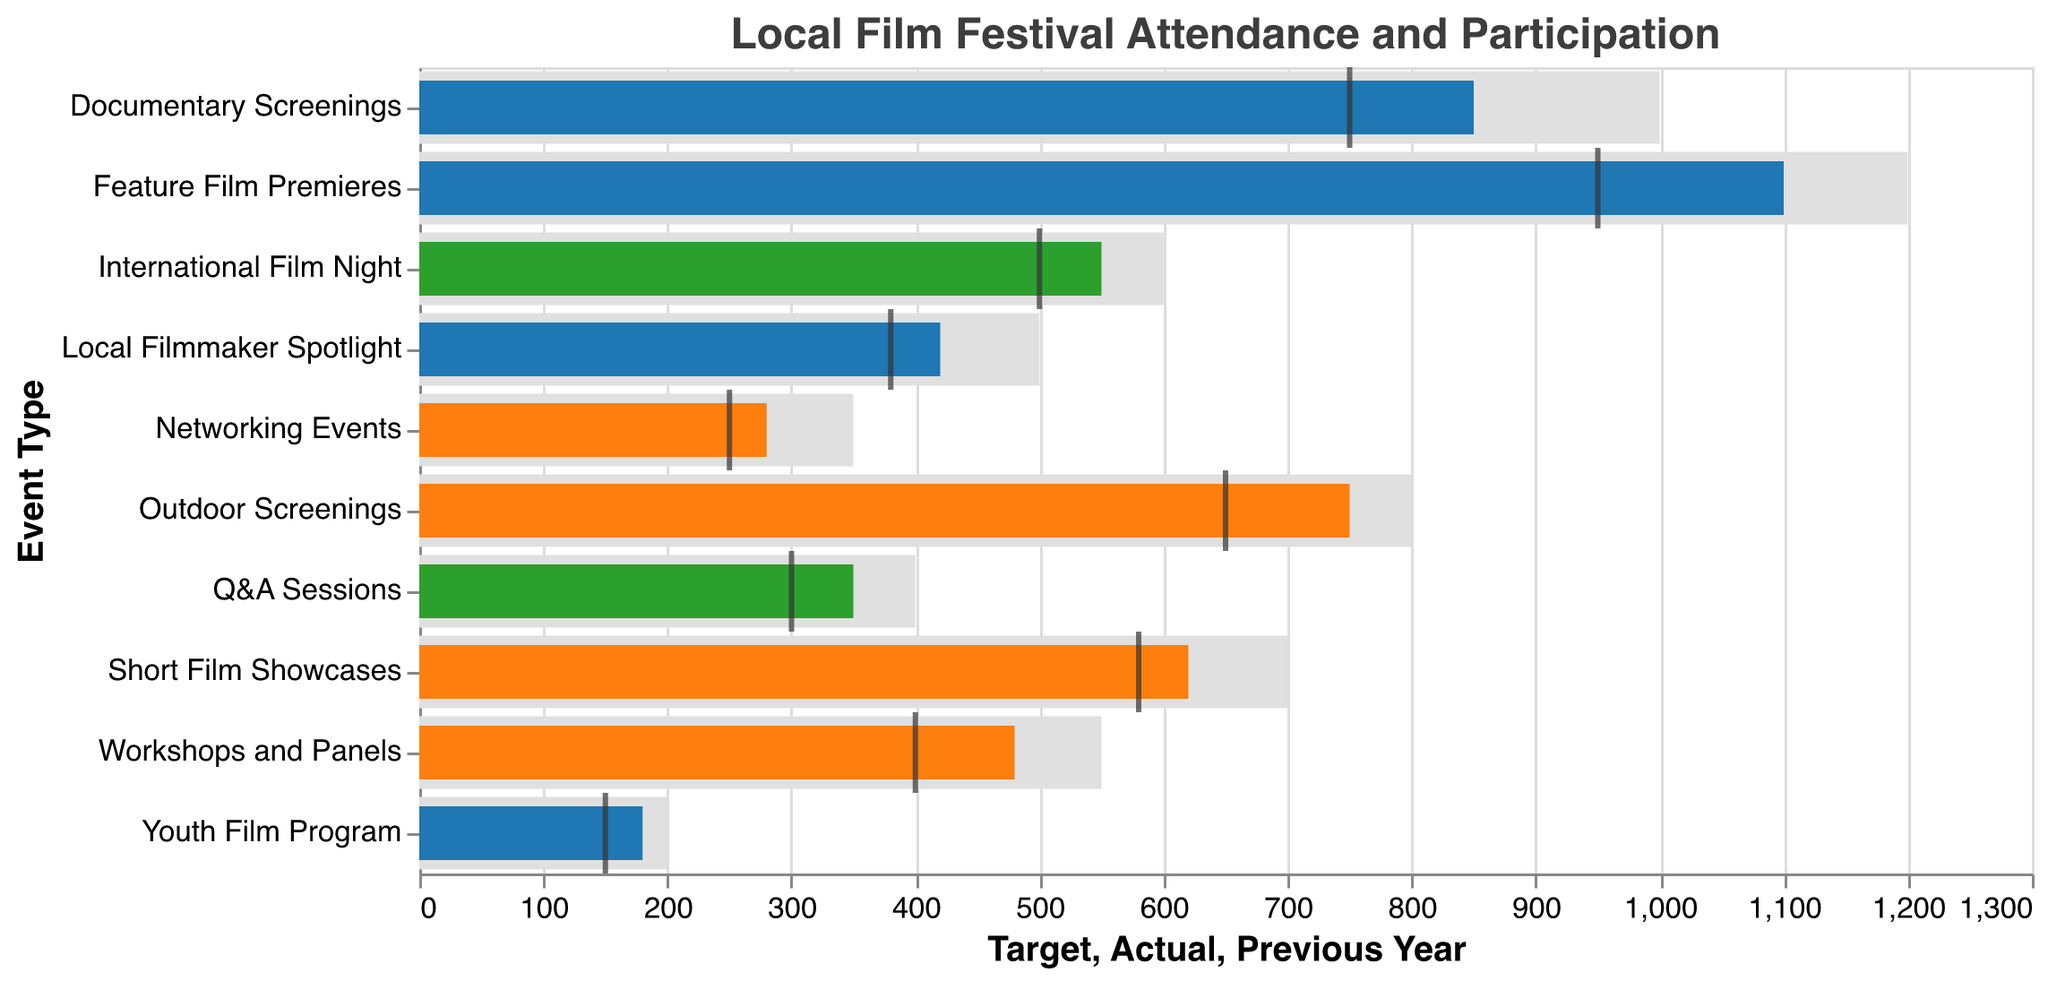What is the title of the figure? The title is displayed at the top of the figure. It reads "Local Film Festival Attendance and Participation".
Answer: Local Film Festival Attendance and Participation How many event types have a high level of community involvement? By looking at the 'Community Involvement' column, count the events with "High" involvement. There are Documentary Screenings, Feature Film Premieres, Youth Film Program, and Local Filmmaker Spotlight.
Answer: 4 Which event type has the highest attendance? Compare the 'Actual' values for all event types. Feature Film Premieres have the highest attendance with 1100.
Answer: Feature Film Premieres What is the attendance difference between Short Film Showcases and Q&A Sessions? Subtract the attendance for Q&A Sessions from Short Film Showcases: 620 - 350 = 270.
Answer: 270 Are there any events where the actual attendance exceeded the target? None of the event types have 'Actual' values higher than 'Target' values in the figure.
Answer: No Which event type has the largest increase in attendance compared to the previous year? Calculate the difference between 'Actual' and 'Previous Year' for each event. The largest increase is for Feature Film Premieres: 1100 - 950 = 150.
Answer: Feature Film Premieres What is the average target attendance for the events? Sum up the 'Target' values and divide by the number of events. (1000 + 700 + 1200 + 550 + 400 + 350 + 200 + 500 + 600 + 800) / 10 = 6300 / 10 = 630.
Answer: 630 Which event type has the smallest difference between actual attendance and the target? Subtract 'Actual' from 'Target' for each event and find the smallest difference. Q&A Sessions have the smallest difference: 400 - 350 = 50.
Answer: Q&A Sessions Do high community involvement events have better attendance compared to other levels? Compare the 'Actual' attendance for high involvement events with medium and low involvement events. High involvement events tend to have higher attendance values (e.g., Documentary Screenings: 850, Feature Film Premieres: 1100).
Answer: Yes 